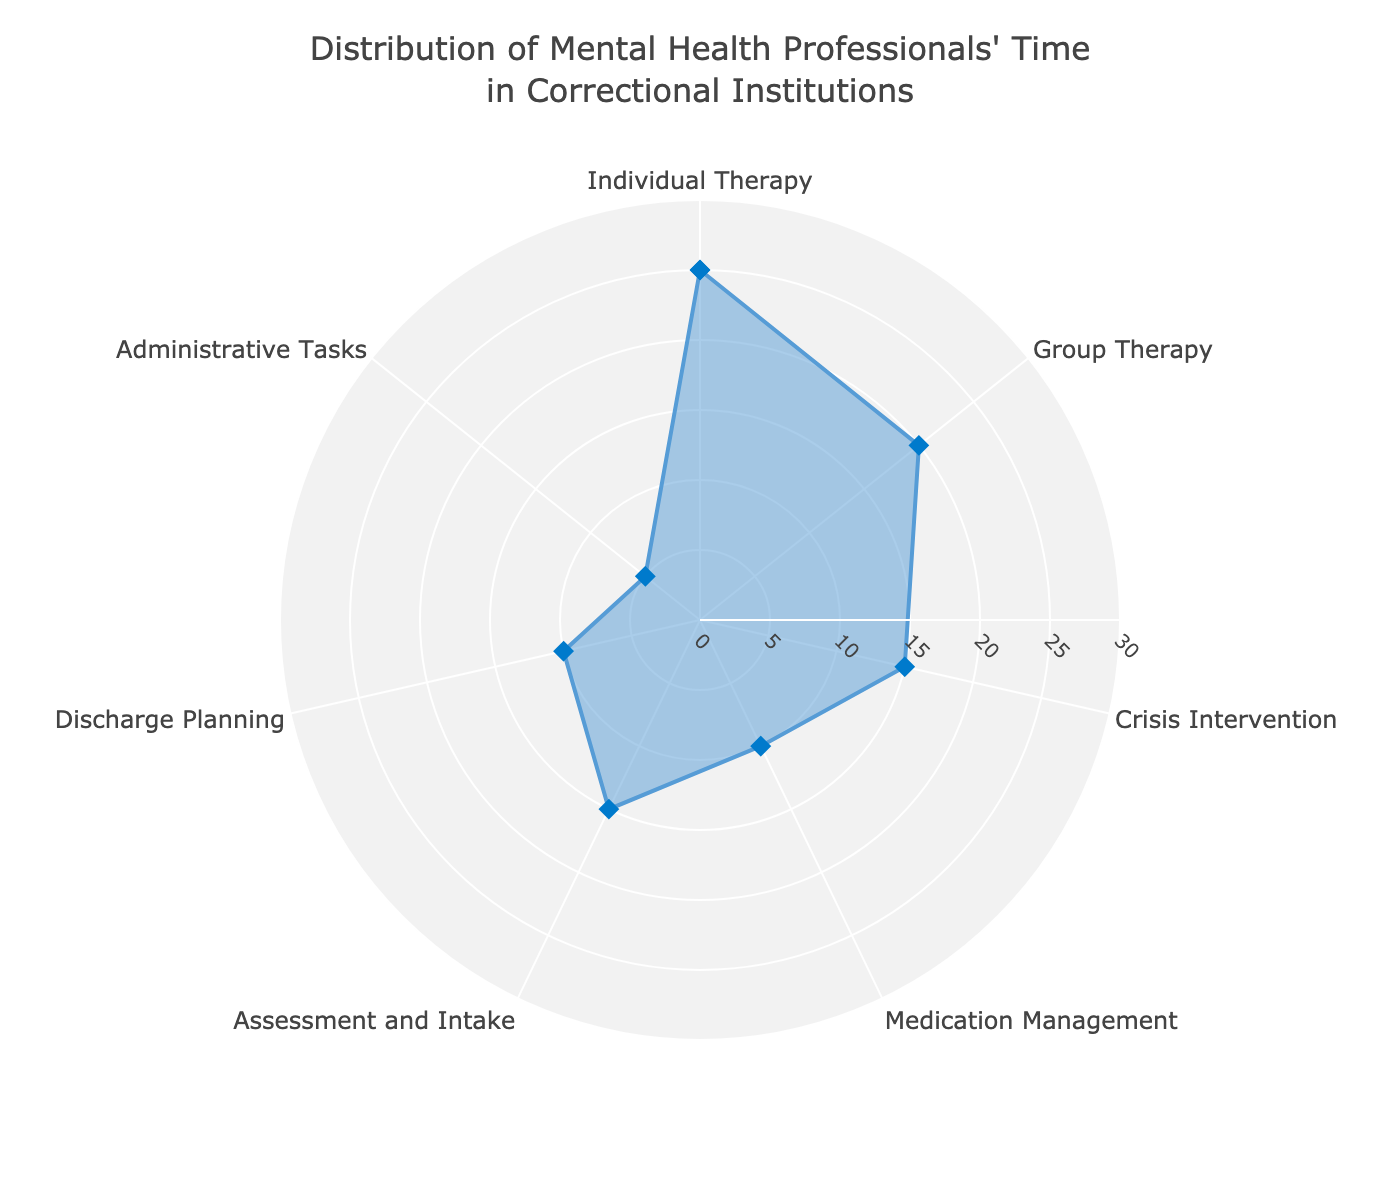What is the title of the radar chart? The title of the radar chart is displayed at the top of the chart and typically summarizes the purpose or the main insight of the chart. It reads "Distribution of Mental Health Professionals' Time in Correctional Institutions".
Answer: Distribution of Mental Health Professionals' Time in Correctional Institutions Which therapeutic activity takes up the largest percentage of mental health professionals' time? The largest percentage in the radar chart corresponds to Individual Therapy, which is indicated at 25%.
Answer: Individual Therapy Which two activities have the same percentage of time allocation? By observing the values on the radar chart, Assessment and Intake and Crisis Intervention both take up 15% of the mental health professionals' time.
Answer: Assessment and Intake, Crisis Intervention How much more time is spent on Individual Therapy than on Administrative Tasks? Individual Therapy takes up 25% of the time, while Administrative Tasks take up 5%. The difference is 25% - 5% = 20%.
Answer: 20% What is the combined percentage of time allocated to Group Therapy and Discharge Planning? Group Therapy takes up 20% and Discharge Planning takes up 10%. The combined percentage is 20% + 10% = 30%.
Answer: 30% Is medication management given more or less time compared to crisis intervention? Medication Management is given 10% of the time, whereas Crisis Intervention is given 15% of the time, indicating less time is spent on Medication Management.
Answer: Less Which activities are allocated the least and most time in the radar chart? The least amount of time is allocated to Administrative Tasks (5%), while the most time is allocated to Individual Therapy (25%).
Answer: Administrative Tasks, Individual Therapy What percentage of time is spent on activities other than Individual Therapy and Group Therapy? Adding percentages of all activities other than Individual and Group Therapy: Crisis Intervention (15%) + Medication Management (10%) + Assessment and Intake (15%) + Discharge Planning (10%) + Administrative Tasks (5%) results in 55%.
Answer: 55% How much more time is spent on Group Therapy compared to Discharge Planning? Group Therapy takes up 20% of the time, while Discharge Planning takes up 10%. The difference is 20% - 10% = 10%.
Answer: 10% What is the average time spent on Medication Management, Assessment and Intake, and Discharge Planning? The combined percentage for these three activities is 10% (Medication Management) + 15% (Assessment and Intake) + 10% (Discharge Planning) = 35%. The average is 35% / 3 = 11.67%.
Answer: 11.67% 